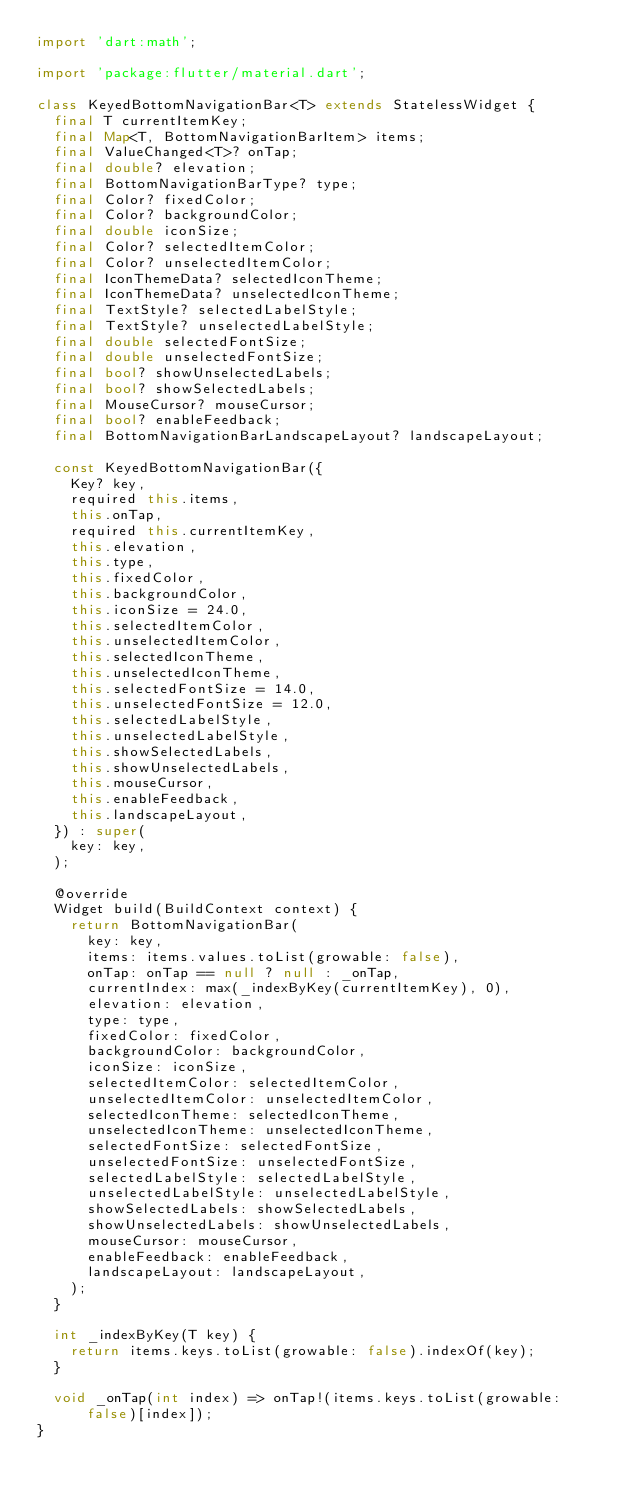Convert code to text. <code><loc_0><loc_0><loc_500><loc_500><_Dart_>import 'dart:math';

import 'package:flutter/material.dart';

class KeyedBottomNavigationBar<T> extends StatelessWidget {
  final T currentItemKey;
  final Map<T, BottomNavigationBarItem> items;
  final ValueChanged<T>? onTap;
  final double? elevation;
  final BottomNavigationBarType? type;
  final Color? fixedColor;
  final Color? backgroundColor;
  final double iconSize;
  final Color? selectedItemColor;
  final Color? unselectedItemColor;
  final IconThemeData? selectedIconTheme;
  final IconThemeData? unselectedIconTheme;
  final TextStyle? selectedLabelStyle;
  final TextStyle? unselectedLabelStyle;
  final double selectedFontSize;
  final double unselectedFontSize;
  final bool? showUnselectedLabels;
  final bool? showSelectedLabels;
  final MouseCursor? mouseCursor;
  final bool? enableFeedback;
  final BottomNavigationBarLandscapeLayout? landscapeLayout;

  const KeyedBottomNavigationBar({
    Key? key,
    required this.items,
    this.onTap,
    required this.currentItemKey,
    this.elevation,
    this.type,
    this.fixedColor,
    this.backgroundColor,
    this.iconSize = 24.0,
    this.selectedItemColor,
    this.unselectedItemColor,
    this.selectedIconTheme,
    this.unselectedIconTheme,
    this.selectedFontSize = 14.0,
    this.unselectedFontSize = 12.0,
    this.selectedLabelStyle,
    this.unselectedLabelStyle,
    this.showSelectedLabels,
    this.showUnselectedLabels,
    this.mouseCursor,
    this.enableFeedback,
    this.landscapeLayout,
  }) : super(
    key: key,
  );

  @override
  Widget build(BuildContext context) {
    return BottomNavigationBar(
      key: key,
      items: items.values.toList(growable: false),
      onTap: onTap == null ? null : _onTap,
      currentIndex: max(_indexByKey(currentItemKey), 0),
      elevation: elevation,
      type: type,
      fixedColor: fixedColor,
      backgroundColor: backgroundColor,
      iconSize: iconSize,
      selectedItemColor: selectedItemColor,
      unselectedItemColor: unselectedItemColor,
      selectedIconTheme: selectedIconTheme,
      unselectedIconTheme: unselectedIconTheme,
      selectedFontSize: selectedFontSize,
      unselectedFontSize: unselectedFontSize,
      selectedLabelStyle: selectedLabelStyle,
      unselectedLabelStyle: unselectedLabelStyle,
      showSelectedLabels: showSelectedLabels,
      showUnselectedLabels: showUnselectedLabels,
      mouseCursor: mouseCursor,
      enableFeedback: enableFeedback,
      landscapeLayout: landscapeLayout,
    );
  }

  int _indexByKey(T key) {
    return items.keys.toList(growable: false).indexOf(key);
  }

  void _onTap(int index) => onTap!(items.keys.toList(growable: false)[index]);
}
</code> 